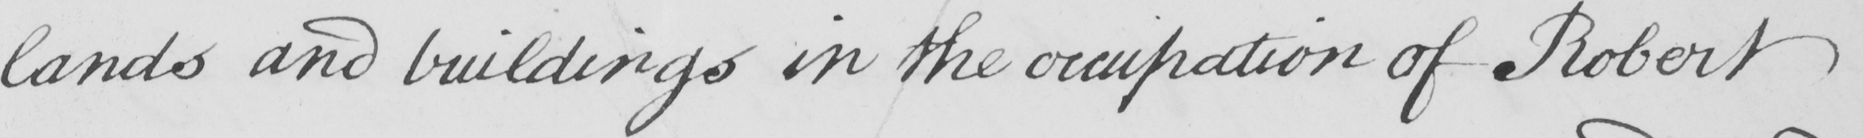Can you tell me what this handwritten text says? lands and buildings in the occupation of Robert 